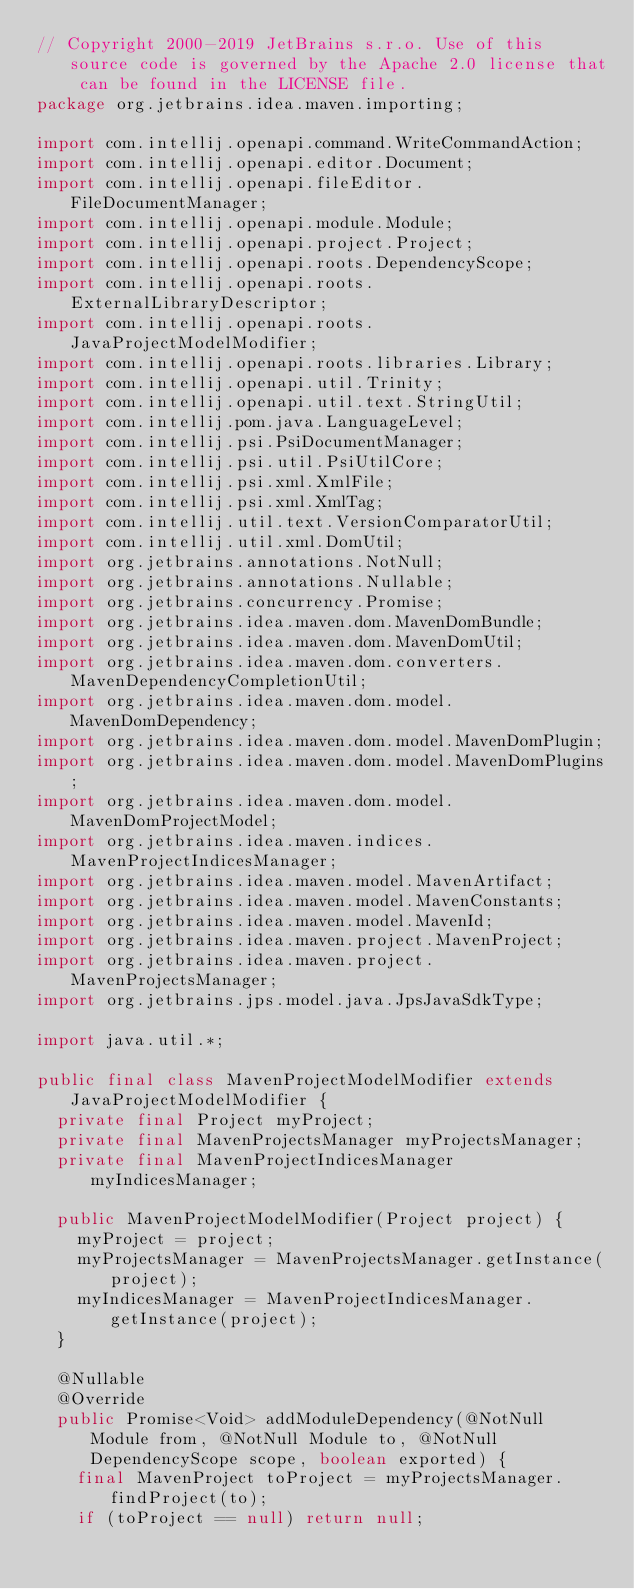Convert code to text. <code><loc_0><loc_0><loc_500><loc_500><_Java_>// Copyright 2000-2019 JetBrains s.r.o. Use of this source code is governed by the Apache 2.0 license that can be found in the LICENSE file.
package org.jetbrains.idea.maven.importing;

import com.intellij.openapi.command.WriteCommandAction;
import com.intellij.openapi.editor.Document;
import com.intellij.openapi.fileEditor.FileDocumentManager;
import com.intellij.openapi.module.Module;
import com.intellij.openapi.project.Project;
import com.intellij.openapi.roots.DependencyScope;
import com.intellij.openapi.roots.ExternalLibraryDescriptor;
import com.intellij.openapi.roots.JavaProjectModelModifier;
import com.intellij.openapi.roots.libraries.Library;
import com.intellij.openapi.util.Trinity;
import com.intellij.openapi.util.text.StringUtil;
import com.intellij.pom.java.LanguageLevel;
import com.intellij.psi.PsiDocumentManager;
import com.intellij.psi.util.PsiUtilCore;
import com.intellij.psi.xml.XmlFile;
import com.intellij.psi.xml.XmlTag;
import com.intellij.util.text.VersionComparatorUtil;
import com.intellij.util.xml.DomUtil;
import org.jetbrains.annotations.NotNull;
import org.jetbrains.annotations.Nullable;
import org.jetbrains.concurrency.Promise;
import org.jetbrains.idea.maven.dom.MavenDomBundle;
import org.jetbrains.idea.maven.dom.MavenDomUtil;
import org.jetbrains.idea.maven.dom.converters.MavenDependencyCompletionUtil;
import org.jetbrains.idea.maven.dom.model.MavenDomDependency;
import org.jetbrains.idea.maven.dom.model.MavenDomPlugin;
import org.jetbrains.idea.maven.dom.model.MavenDomPlugins;
import org.jetbrains.idea.maven.dom.model.MavenDomProjectModel;
import org.jetbrains.idea.maven.indices.MavenProjectIndicesManager;
import org.jetbrains.idea.maven.model.MavenArtifact;
import org.jetbrains.idea.maven.model.MavenConstants;
import org.jetbrains.idea.maven.model.MavenId;
import org.jetbrains.idea.maven.project.MavenProject;
import org.jetbrains.idea.maven.project.MavenProjectsManager;
import org.jetbrains.jps.model.java.JpsJavaSdkType;

import java.util.*;

public final class MavenProjectModelModifier extends JavaProjectModelModifier {
  private final Project myProject;
  private final MavenProjectsManager myProjectsManager;
  private final MavenProjectIndicesManager myIndicesManager;

  public MavenProjectModelModifier(Project project) {
    myProject = project;
    myProjectsManager = MavenProjectsManager.getInstance(project);
    myIndicesManager = MavenProjectIndicesManager.getInstance(project);
  }

  @Nullable
  @Override
  public Promise<Void> addModuleDependency(@NotNull Module from, @NotNull Module to, @NotNull DependencyScope scope, boolean exported) {
    final MavenProject toProject = myProjectsManager.findProject(to);
    if (toProject == null) return null;</code> 